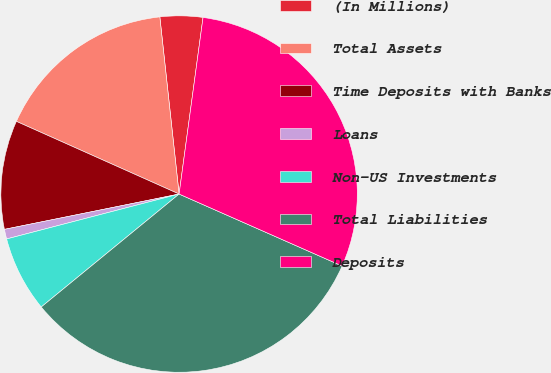Convert chart to OTSL. <chart><loc_0><loc_0><loc_500><loc_500><pie_chart><fcel>(In Millions)<fcel>Total Assets<fcel>Time Deposits with Banks<fcel>Loans<fcel>Non-US Investments<fcel>Total Liabilities<fcel>Deposits<nl><fcel>3.87%<fcel>16.59%<fcel>9.86%<fcel>0.88%<fcel>6.87%<fcel>32.46%<fcel>29.47%<nl></chart> 